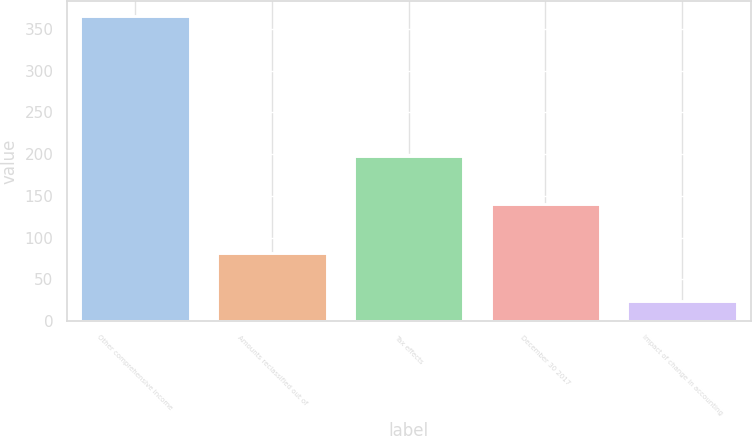Convert chart. <chart><loc_0><loc_0><loc_500><loc_500><bar_chart><fcel>Other comprehensive income<fcel>Amounts reclassified out of<fcel>Tax effects<fcel>December 30 2017<fcel>Impact of change in accounting<nl><fcel>365<fcel>82.1<fcel>198.3<fcel>140.2<fcel>24<nl></chart> 